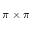Convert formula to latex. <formula><loc_0><loc_0><loc_500><loc_500>\pi \times \pi</formula> 